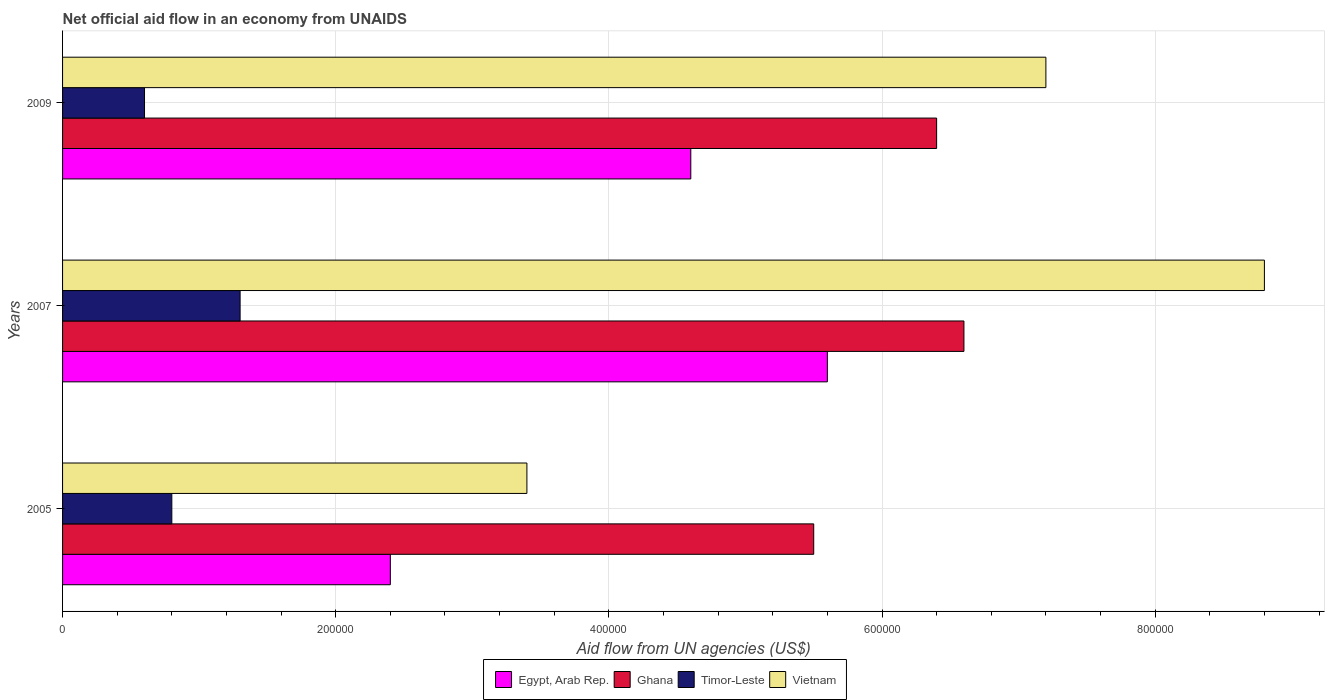How many different coloured bars are there?
Your answer should be very brief. 4. How many groups of bars are there?
Your answer should be compact. 3. What is the label of the 1st group of bars from the top?
Your response must be concise. 2009. What is the net official aid flow in Vietnam in 2009?
Your answer should be compact. 7.20e+05. Across all years, what is the maximum net official aid flow in Vietnam?
Keep it short and to the point. 8.80e+05. Across all years, what is the minimum net official aid flow in Vietnam?
Ensure brevity in your answer.  3.40e+05. In which year was the net official aid flow in Ghana minimum?
Keep it short and to the point. 2005. What is the total net official aid flow in Egypt, Arab Rep. in the graph?
Provide a succinct answer. 1.26e+06. What is the difference between the net official aid flow in Ghana in 2005 and that in 2009?
Offer a very short reply. -9.00e+04. What is the difference between the net official aid flow in Vietnam in 2005 and the net official aid flow in Ghana in 2009?
Provide a succinct answer. -3.00e+05. What is the average net official aid flow in Vietnam per year?
Your response must be concise. 6.47e+05. In the year 2007, what is the difference between the net official aid flow in Ghana and net official aid flow in Vietnam?
Give a very brief answer. -2.20e+05. What is the ratio of the net official aid flow in Timor-Leste in 2005 to that in 2009?
Your answer should be compact. 1.33. What is the difference between the highest and the lowest net official aid flow in Egypt, Arab Rep.?
Keep it short and to the point. 3.20e+05. Is the sum of the net official aid flow in Egypt, Arab Rep. in 2007 and 2009 greater than the maximum net official aid flow in Vietnam across all years?
Your answer should be compact. Yes. What does the 1st bar from the bottom in 2007 represents?
Make the answer very short. Egypt, Arab Rep. Is it the case that in every year, the sum of the net official aid flow in Egypt, Arab Rep. and net official aid flow in Vietnam is greater than the net official aid flow in Ghana?
Give a very brief answer. Yes. How many bars are there?
Provide a short and direct response. 12. What is the difference between two consecutive major ticks on the X-axis?
Ensure brevity in your answer.  2.00e+05. Are the values on the major ticks of X-axis written in scientific E-notation?
Give a very brief answer. No. Does the graph contain grids?
Provide a short and direct response. Yes. What is the title of the graph?
Make the answer very short. Net official aid flow in an economy from UNAIDS. Does "Slovenia" appear as one of the legend labels in the graph?
Your answer should be compact. No. What is the label or title of the X-axis?
Provide a succinct answer. Aid flow from UN agencies (US$). What is the label or title of the Y-axis?
Provide a succinct answer. Years. What is the Aid flow from UN agencies (US$) in Egypt, Arab Rep. in 2005?
Your answer should be very brief. 2.40e+05. What is the Aid flow from UN agencies (US$) of Ghana in 2005?
Make the answer very short. 5.50e+05. What is the Aid flow from UN agencies (US$) of Timor-Leste in 2005?
Provide a short and direct response. 8.00e+04. What is the Aid flow from UN agencies (US$) in Egypt, Arab Rep. in 2007?
Make the answer very short. 5.60e+05. What is the Aid flow from UN agencies (US$) of Timor-Leste in 2007?
Offer a terse response. 1.30e+05. What is the Aid flow from UN agencies (US$) of Vietnam in 2007?
Your answer should be very brief. 8.80e+05. What is the Aid flow from UN agencies (US$) of Egypt, Arab Rep. in 2009?
Give a very brief answer. 4.60e+05. What is the Aid flow from UN agencies (US$) in Ghana in 2009?
Provide a succinct answer. 6.40e+05. What is the Aid flow from UN agencies (US$) in Timor-Leste in 2009?
Ensure brevity in your answer.  6.00e+04. What is the Aid flow from UN agencies (US$) in Vietnam in 2009?
Provide a succinct answer. 7.20e+05. Across all years, what is the maximum Aid flow from UN agencies (US$) in Egypt, Arab Rep.?
Offer a very short reply. 5.60e+05. Across all years, what is the maximum Aid flow from UN agencies (US$) in Vietnam?
Ensure brevity in your answer.  8.80e+05. Across all years, what is the minimum Aid flow from UN agencies (US$) of Egypt, Arab Rep.?
Ensure brevity in your answer.  2.40e+05. Across all years, what is the minimum Aid flow from UN agencies (US$) in Ghana?
Offer a terse response. 5.50e+05. Across all years, what is the minimum Aid flow from UN agencies (US$) of Timor-Leste?
Your answer should be very brief. 6.00e+04. Across all years, what is the minimum Aid flow from UN agencies (US$) in Vietnam?
Keep it short and to the point. 3.40e+05. What is the total Aid flow from UN agencies (US$) in Egypt, Arab Rep. in the graph?
Make the answer very short. 1.26e+06. What is the total Aid flow from UN agencies (US$) in Ghana in the graph?
Your answer should be compact. 1.85e+06. What is the total Aid flow from UN agencies (US$) in Timor-Leste in the graph?
Ensure brevity in your answer.  2.70e+05. What is the total Aid flow from UN agencies (US$) of Vietnam in the graph?
Your response must be concise. 1.94e+06. What is the difference between the Aid flow from UN agencies (US$) in Egypt, Arab Rep. in 2005 and that in 2007?
Make the answer very short. -3.20e+05. What is the difference between the Aid flow from UN agencies (US$) in Ghana in 2005 and that in 2007?
Keep it short and to the point. -1.10e+05. What is the difference between the Aid flow from UN agencies (US$) of Vietnam in 2005 and that in 2007?
Make the answer very short. -5.40e+05. What is the difference between the Aid flow from UN agencies (US$) of Vietnam in 2005 and that in 2009?
Make the answer very short. -3.80e+05. What is the difference between the Aid flow from UN agencies (US$) of Ghana in 2007 and that in 2009?
Your answer should be very brief. 2.00e+04. What is the difference between the Aid flow from UN agencies (US$) of Timor-Leste in 2007 and that in 2009?
Ensure brevity in your answer.  7.00e+04. What is the difference between the Aid flow from UN agencies (US$) in Egypt, Arab Rep. in 2005 and the Aid flow from UN agencies (US$) in Ghana in 2007?
Offer a terse response. -4.20e+05. What is the difference between the Aid flow from UN agencies (US$) of Egypt, Arab Rep. in 2005 and the Aid flow from UN agencies (US$) of Timor-Leste in 2007?
Give a very brief answer. 1.10e+05. What is the difference between the Aid flow from UN agencies (US$) of Egypt, Arab Rep. in 2005 and the Aid flow from UN agencies (US$) of Vietnam in 2007?
Offer a very short reply. -6.40e+05. What is the difference between the Aid flow from UN agencies (US$) in Ghana in 2005 and the Aid flow from UN agencies (US$) in Timor-Leste in 2007?
Offer a terse response. 4.20e+05. What is the difference between the Aid flow from UN agencies (US$) in Ghana in 2005 and the Aid flow from UN agencies (US$) in Vietnam in 2007?
Ensure brevity in your answer.  -3.30e+05. What is the difference between the Aid flow from UN agencies (US$) in Timor-Leste in 2005 and the Aid flow from UN agencies (US$) in Vietnam in 2007?
Your answer should be very brief. -8.00e+05. What is the difference between the Aid flow from UN agencies (US$) of Egypt, Arab Rep. in 2005 and the Aid flow from UN agencies (US$) of Ghana in 2009?
Ensure brevity in your answer.  -4.00e+05. What is the difference between the Aid flow from UN agencies (US$) in Egypt, Arab Rep. in 2005 and the Aid flow from UN agencies (US$) in Vietnam in 2009?
Your answer should be very brief. -4.80e+05. What is the difference between the Aid flow from UN agencies (US$) in Ghana in 2005 and the Aid flow from UN agencies (US$) in Timor-Leste in 2009?
Provide a short and direct response. 4.90e+05. What is the difference between the Aid flow from UN agencies (US$) of Timor-Leste in 2005 and the Aid flow from UN agencies (US$) of Vietnam in 2009?
Your answer should be very brief. -6.40e+05. What is the difference between the Aid flow from UN agencies (US$) of Egypt, Arab Rep. in 2007 and the Aid flow from UN agencies (US$) of Ghana in 2009?
Keep it short and to the point. -8.00e+04. What is the difference between the Aid flow from UN agencies (US$) in Egypt, Arab Rep. in 2007 and the Aid flow from UN agencies (US$) in Timor-Leste in 2009?
Give a very brief answer. 5.00e+05. What is the difference between the Aid flow from UN agencies (US$) of Egypt, Arab Rep. in 2007 and the Aid flow from UN agencies (US$) of Vietnam in 2009?
Make the answer very short. -1.60e+05. What is the difference between the Aid flow from UN agencies (US$) in Timor-Leste in 2007 and the Aid flow from UN agencies (US$) in Vietnam in 2009?
Keep it short and to the point. -5.90e+05. What is the average Aid flow from UN agencies (US$) in Egypt, Arab Rep. per year?
Provide a succinct answer. 4.20e+05. What is the average Aid flow from UN agencies (US$) in Ghana per year?
Make the answer very short. 6.17e+05. What is the average Aid flow from UN agencies (US$) in Timor-Leste per year?
Offer a very short reply. 9.00e+04. What is the average Aid flow from UN agencies (US$) of Vietnam per year?
Provide a short and direct response. 6.47e+05. In the year 2005, what is the difference between the Aid flow from UN agencies (US$) of Egypt, Arab Rep. and Aid flow from UN agencies (US$) of Ghana?
Provide a short and direct response. -3.10e+05. In the year 2005, what is the difference between the Aid flow from UN agencies (US$) in Egypt, Arab Rep. and Aid flow from UN agencies (US$) in Timor-Leste?
Keep it short and to the point. 1.60e+05. In the year 2005, what is the difference between the Aid flow from UN agencies (US$) of Egypt, Arab Rep. and Aid flow from UN agencies (US$) of Vietnam?
Your response must be concise. -1.00e+05. In the year 2005, what is the difference between the Aid flow from UN agencies (US$) in Ghana and Aid flow from UN agencies (US$) in Vietnam?
Provide a short and direct response. 2.10e+05. In the year 2007, what is the difference between the Aid flow from UN agencies (US$) in Egypt, Arab Rep. and Aid flow from UN agencies (US$) in Timor-Leste?
Provide a succinct answer. 4.30e+05. In the year 2007, what is the difference between the Aid flow from UN agencies (US$) in Egypt, Arab Rep. and Aid flow from UN agencies (US$) in Vietnam?
Offer a terse response. -3.20e+05. In the year 2007, what is the difference between the Aid flow from UN agencies (US$) in Ghana and Aid flow from UN agencies (US$) in Timor-Leste?
Make the answer very short. 5.30e+05. In the year 2007, what is the difference between the Aid flow from UN agencies (US$) of Ghana and Aid flow from UN agencies (US$) of Vietnam?
Offer a very short reply. -2.20e+05. In the year 2007, what is the difference between the Aid flow from UN agencies (US$) in Timor-Leste and Aid flow from UN agencies (US$) in Vietnam?
Provide a succinct answer. -7.50e+05. In the year 2009, what is the difference between the Aid flow from UN agencies (US$) in Egypt, Arab Rep. and Aid flow from UN agencies (US$) in Ghana?
Provide a short and direct response. -1.80e+05. In the year 2009, what is the difference between the Aid flow from UN agencies (US$) of Egypt, Arab Rep. and Aid flow from UN agencies (US$) of Timor-Leste?
Your answer should be very brief. 4.00e+05. In the year 2009, what is the difference between the Aid flow from UN agencies (US$) in Egypt, Arab Rep. and Aid flow from UN agencies (US$) in Vietnam?
Keep it short and to the point. -2.60e+05. In the year 2009, what is the difference between the Aid flow from UN agencies (US$) in Ghana and Aid flow from UN agencies (US$) in Timor-Leste?
Give a very brief answer. 5.80e+05. In the year 2009, what is the difference between the Aid flow from UN agencies (US$) of Ghana and Aid flow from UN agencies (US$) of Vietnam?
Your response must be concise. -8.00e+04. In the year 2009, what is the difference between the Aid flow from UN agencies (US$) of Timor-Leste and Aid flow from UN agencies (US$) of Vietnam?
Give a very brief answer. -6.60e+05. What is the ratio of the Aid flow from UN agencies (US$) of Egypt, Arab Rep. in 2005 to that in 2007?
Give a very brief answer. 0.43. What is the ratio of the Aid flow from UN agencies (US$) in Timor-Leste in 2005 to that in 2007?
Provide a short and direct response. 0.62. What is the ratio of the Aid flow from UN agencies (US$) in Vietnam in 2005 to that in 2007?
Offer a very short reply. 0.39. What is the ratio of the Aid flow from UN agencies (US$) in Egypt, Arab Rep. in 2005 to that in 2009?
Your answer should be very brief. 0.52. What is the ratio of the Aid flow from UN agencies (US$) in Ghana in 2005 to that in 2009?
Ensure brevity in your answer.  0.86. What is the ratio of the Aid flow from UN agencies (US$) of Timor-Leste in 2005 to that in 2009?
Keep it short and to the point. 1.33. What is the ratio of the Aid flow from UN agencies (US$) of Vietnam in 2005 to that in 2009?
Give a very brief answer. 0.47. What is the ratio of the Aid flow from UN agencies (US$) of Egypt, Arab Rep. in 2007 to that in 2009?
Ensure brevity in your answer.  1.22. What is the ratio of the Aid flow from UN agencies (US$) of Ghana in 2007 to that in 2009?
Make the answer very short. 1.03. What is the ratio of the Aid flow from UN agencies (US$) in Timor-Leste in 2007 to that in 2009?
Your answer should be compact. 2.17. What is the ratio of the Aid flow from UN agencies (US$) of Vietnam in 2007 to that in 2009?
Your answer should be very brief. 1.22. What is the difference between the highest and the second highest Aid flow from UN agencies (US$) in Egypt, Arab Rep.?
Make the answer very short. 1.00e+05. What is the difference between the highest and the second highest Aid flow from UN agencies (US$) of Timor-Leste?
Your answer should be very brief. 5.00e+04. What is the difference between the highest and the lowest Aid flow from UN agencies (US$) in Ghana?
Give a very brief answer. 1.10e+05. What is the difference between the highest and the lowest Aid flow from UN agencies (US$) of Vietnam?
Provide a short and direct response. 5.40e+05. 